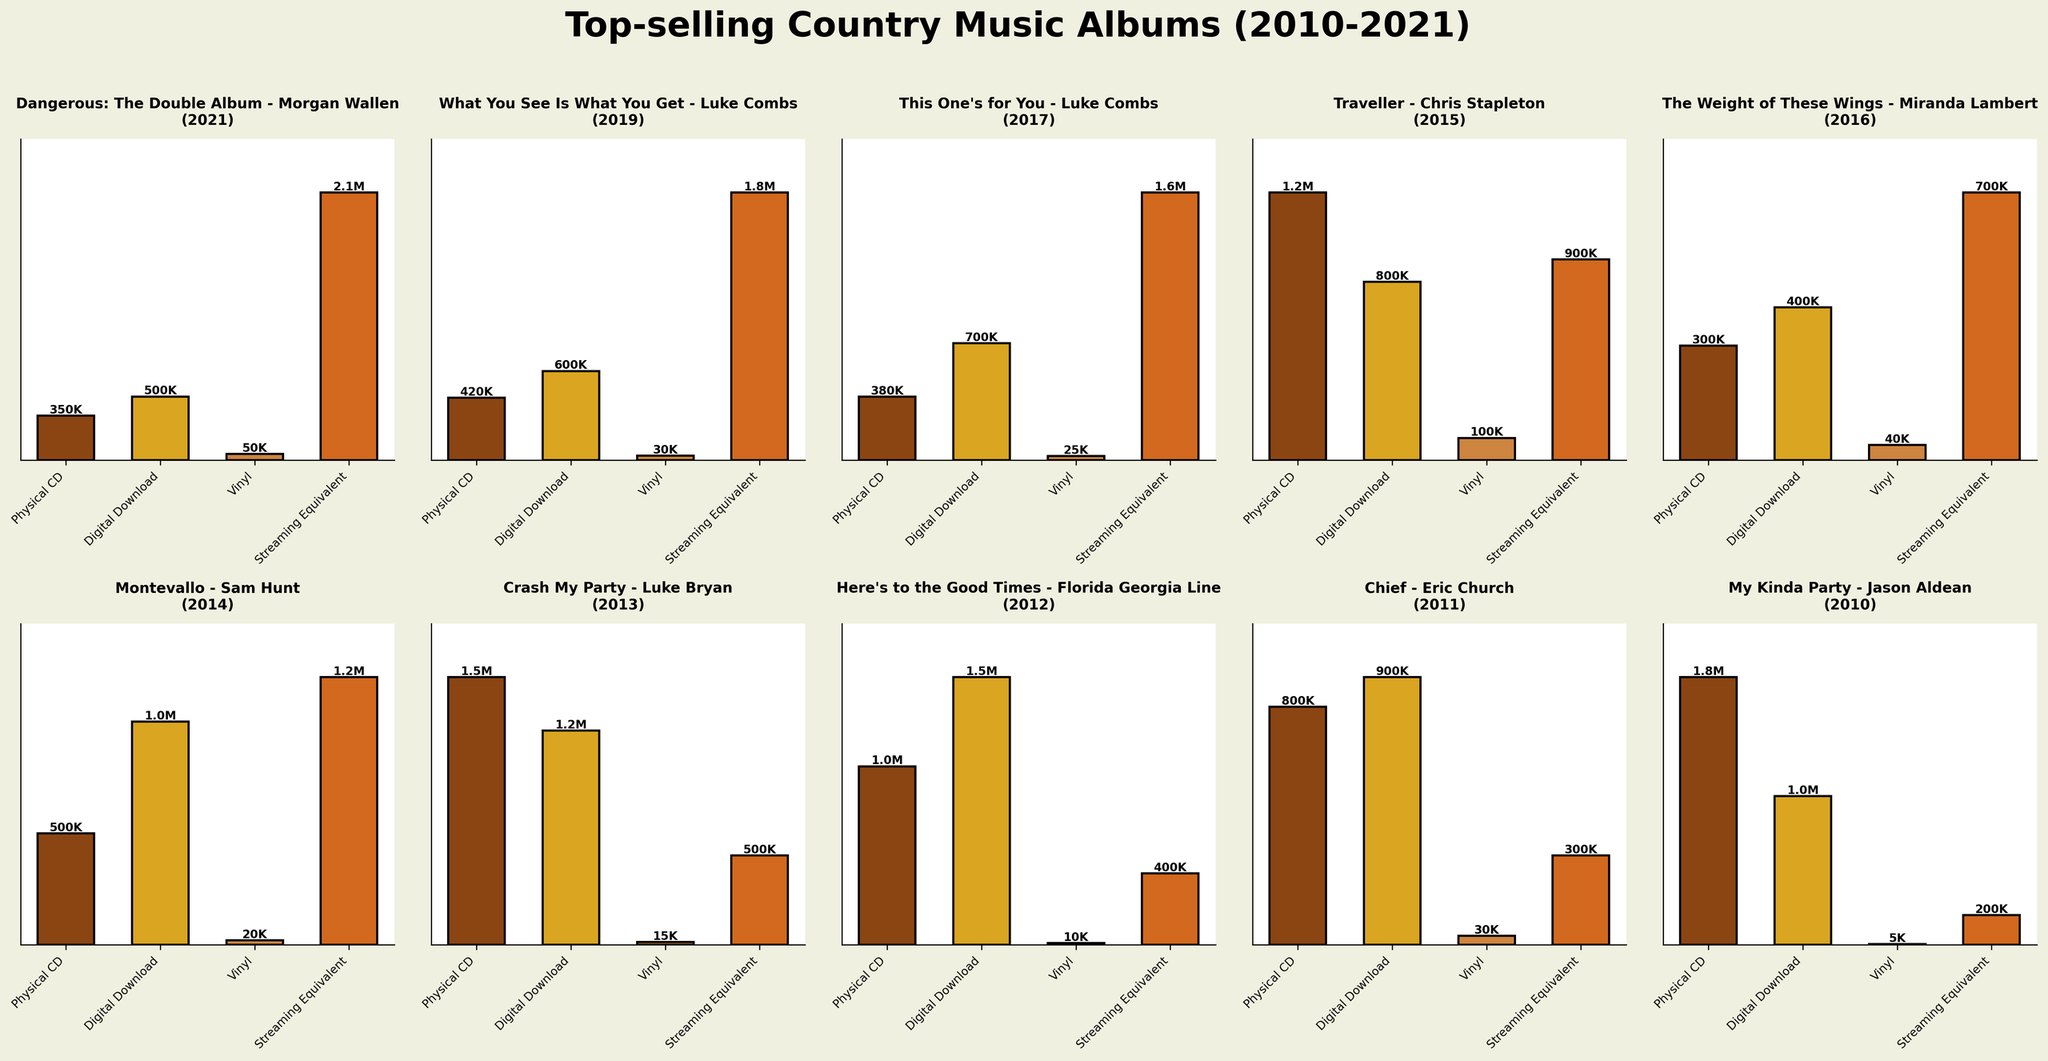How many albums are displayed in the figure? There are 10 albums displayed in the figure, arranged in a 2x5 grid.
Answer: 10 Which album has the highest sales in Physical CDs? By examining the heights of the bars in the "Physical CD" category, we see that "My Kinda Party" by Jason Aldean has the highest sales.
Answer: "My Kinda Party" For "Crash My Party" by Luke Bryan, which sales format has the lowest numbers? For "Crash My Party," the bar corresponding to Vinyl sales is the shortest, indicating it has the lowest numbers.
Answer: Vinyl Compare the total sales of "Montevallo" and "Traveller" in Digital Downloads. Which one is higher? "Montevallo" has 1,000,000 Digital Downloads sales and "Traveller" has 800,000. Therefore, "Montevallo" has higher Digital Downloads sales.
Answer: "Montevallo" What is the difference in Vinyl sales between "Dangerous: The Double Album" and "The Weight of These Wings"? "Dangerous: The Double Album" has 50,000 Vinyl sales and "The Weight of These Wings" has 40,000. The difference is 50,000 - 40,000 = 10,000.
Answer: 10,000 Which album sold more in Streaming Equivalent: "Here's to the Good Times" or "What You See Is What You Get"? "What You See Is What You Get" has 1,800,000 Streaming Equivalent sales, and "Here's to the Good Times" has 400,000. So, "What You See Is What You Get" sold more.
Answer: "What You See Is What You Get" Calculate the average sales of "Chief" by Eric Church across all formats. Adding up the sales across all formats: 800,000 (Physical CD) + 900,000 (Digital Download) + 30,000 (Vinyl) + 300,000 (Streaming Equivalent) = 2,030,000. Dividing by 4 formats: 2,030,000 / 4 = 507,500.
Answer: 507,500 Identify the album with the highest total sales by summing up all formats. Sum up the sales of each album and identify the one with the highest sum. "Dangerous: The Double Album" has the highest total sales: 350,000 (Physical CD) + 500,000 (Digital Download) + 50,000 (Vinyl) + 2,100,000 (Streaming Equivalent) = 3,000,000.
Answer: "Dangerous: The Double Album" Which format consistently has the lowest sales across the albums? By examining all subplots, we notice that Vinyl consistently has the lowest sales compared to Physical CD, Digital Download, and Streaming Equivalent.
Answer: Vinyl Between "Traveller" and "This One's for You," which album has higher overall Physical CD sales? "Traveller" has 1,200,000 Physical CD sales and "This One's for You" has 380,000. Thus, "Traveller" has higher Physical CD sales.
Answer: "Traveller" 